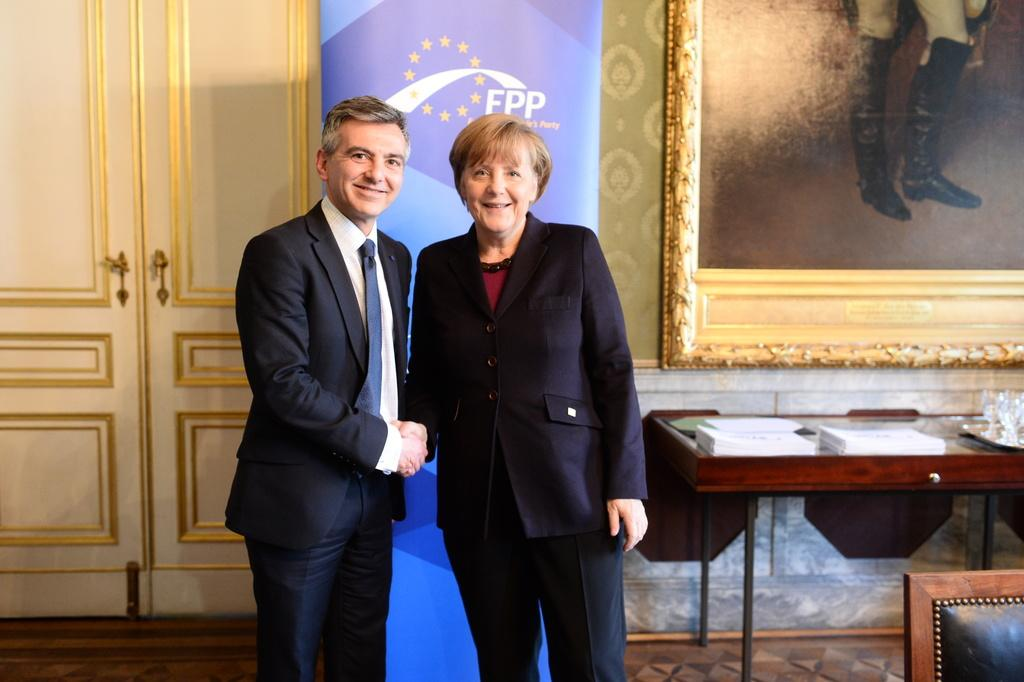How many people are in the image? There are two persons standing in the image. What can be seen in the background of the image? There is a door, a banner, a wall, and a frame in the background of the image. What objects are on the table in the background of the image? There are books and glasses on a table in the background of the image. What is visible on the floor in the image? The floor is visible in the image. What type of snake is wrapped around the banner in the image? There is no snake present in the image; it only features a door, a banner, a wall, and a frame in the background. What language is written on the banner in the image? The provided facts do not mention any text or language on the banner, so it cannot be determined from the image. 